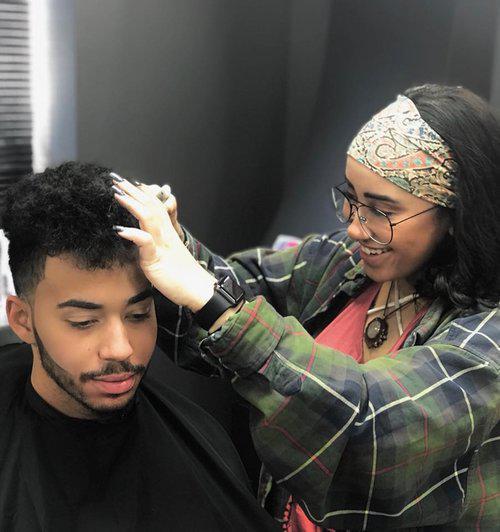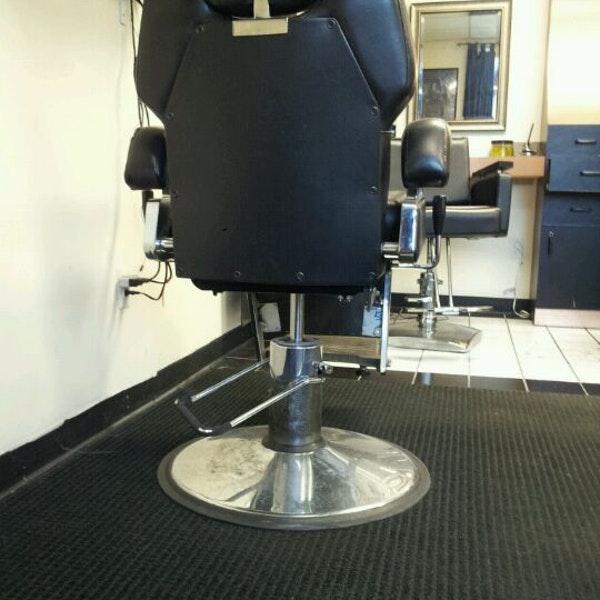The first image is the image on the left, the second image is the image on the right. Given the left and right images, does the statement "A woman is working on a man's hair in the left image." hold true? Answer yes or no. Yes. The first image is the image on the left, the second image is the image on the right. Evaluate the accuracy of this statement regarding the images: "A woman works on a man's hair in the image on the left.". Is it true? Answer yes or no. Yes. 